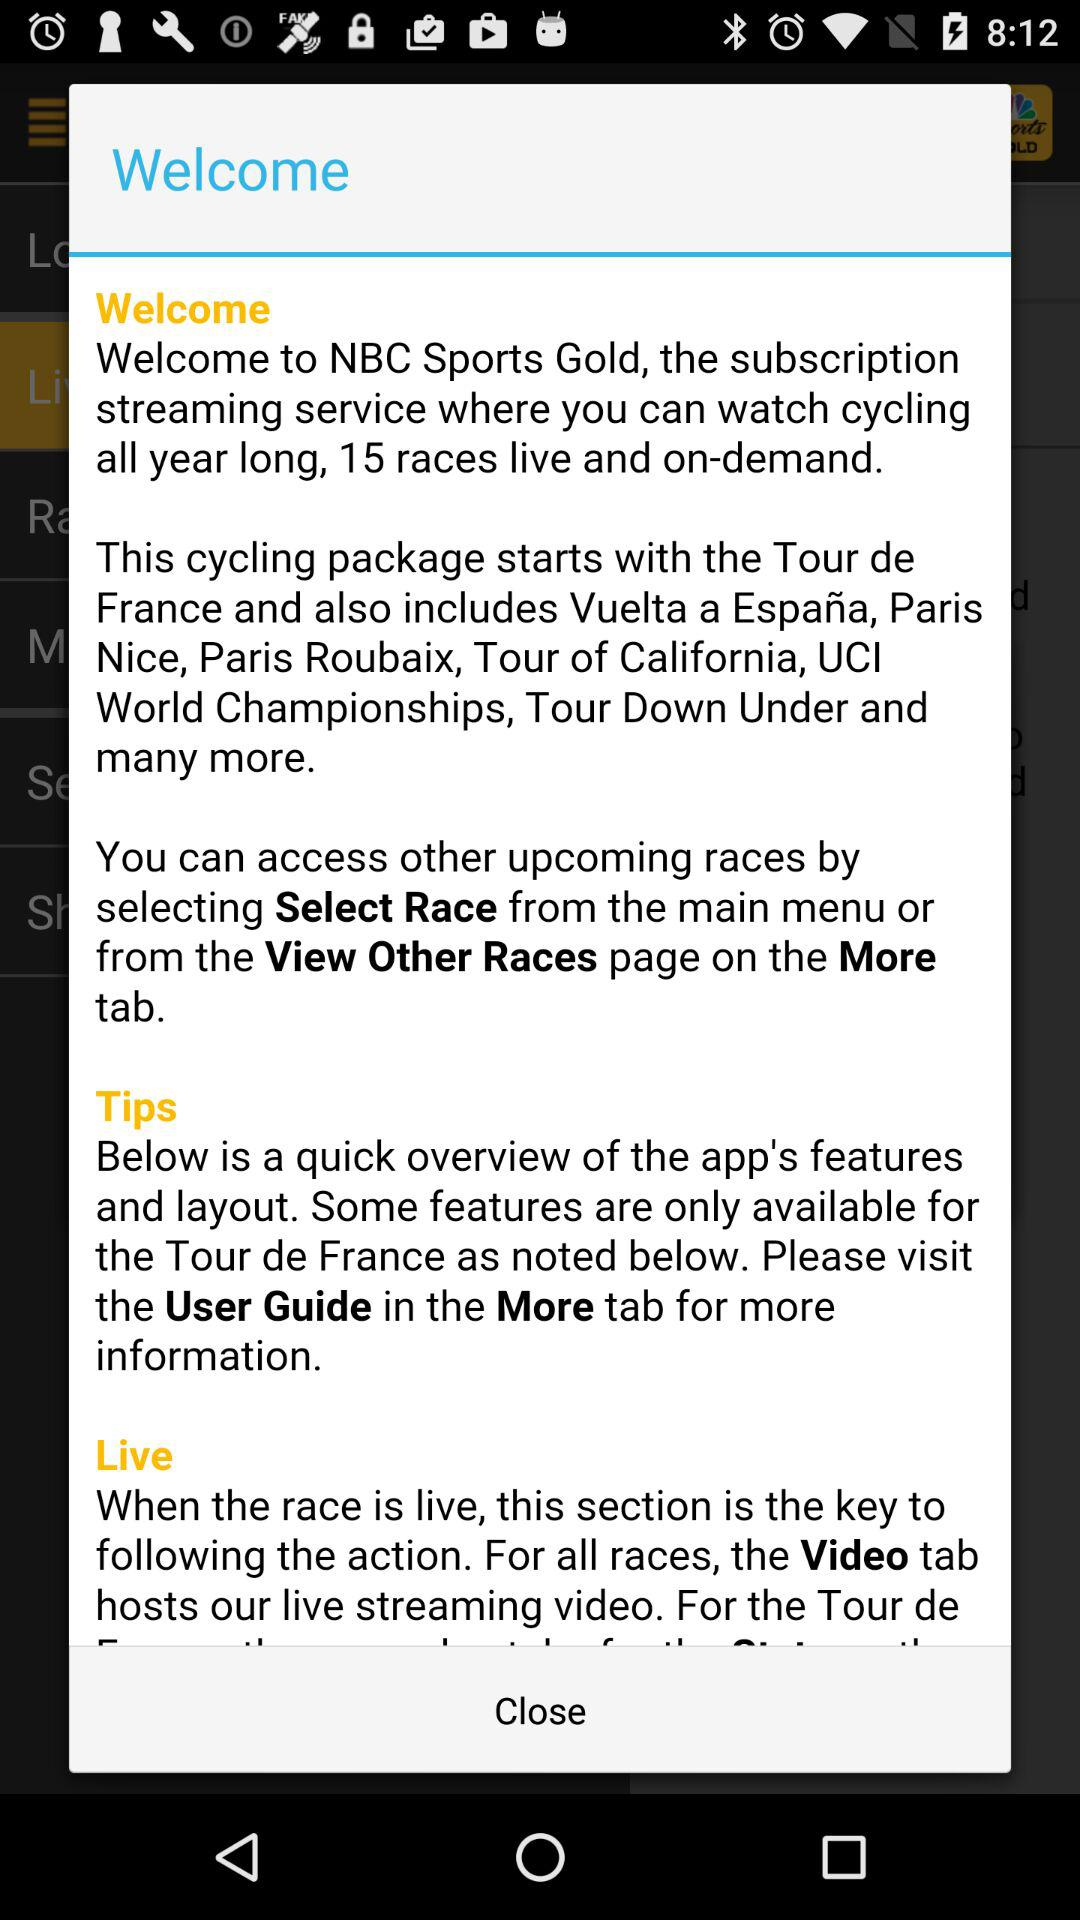How many races are available in the subscription?
Answer the question using a single word or phrase. 15 